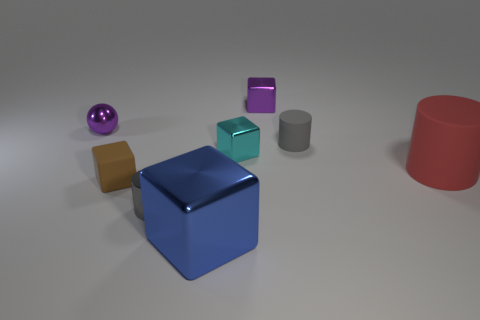Does the lighting in the image suggest a particular time of day or environment? The lighting in the image appears neutral and artificial, indicating it likely takes place indoors under controlled lighting conditions rather than suggesting a specific time of day outdoors. 